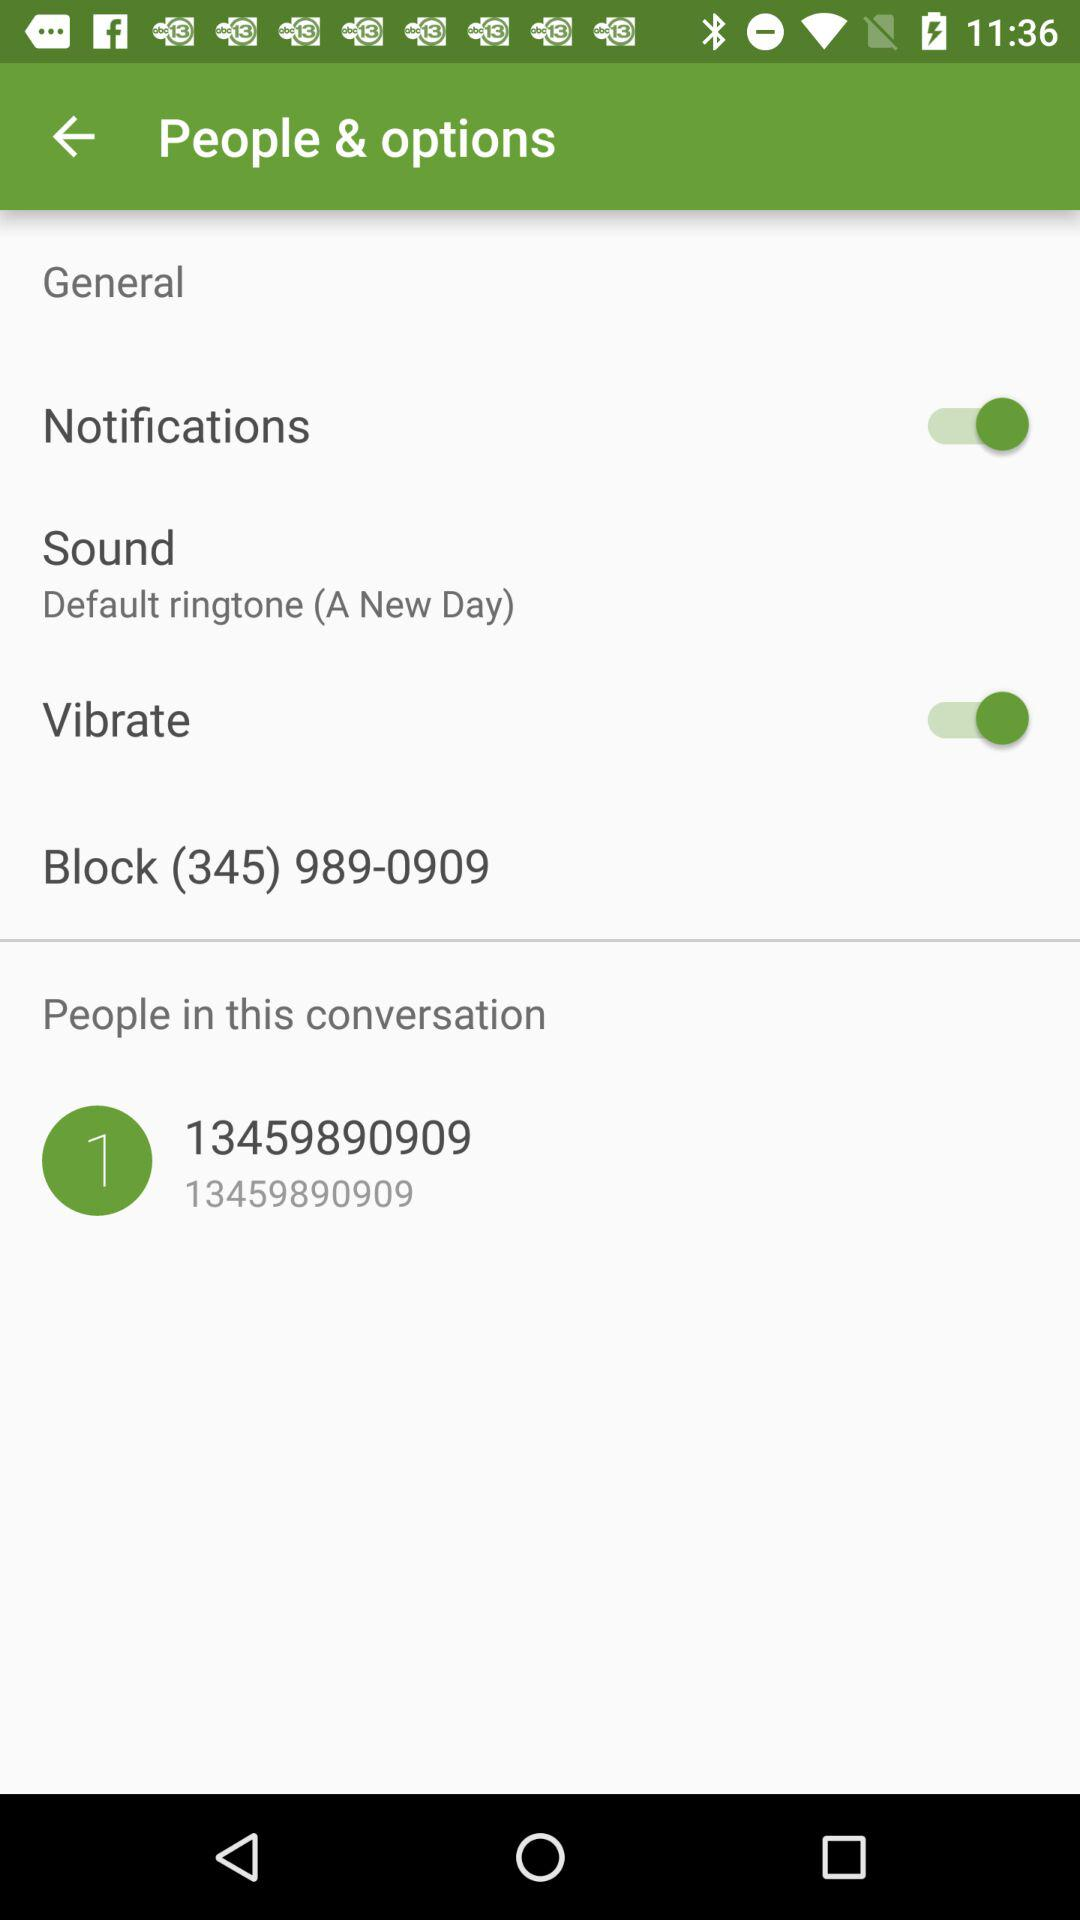How many ringtone options are available?
When the provided information is insufficient, respond with <no answer>. <no answer> 